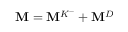Convert formula to latex. <formula><loc_0><loc_0><loc_500><loc_500>M = M ^ { K ^ { - } } + M ^ { D }</formula> 